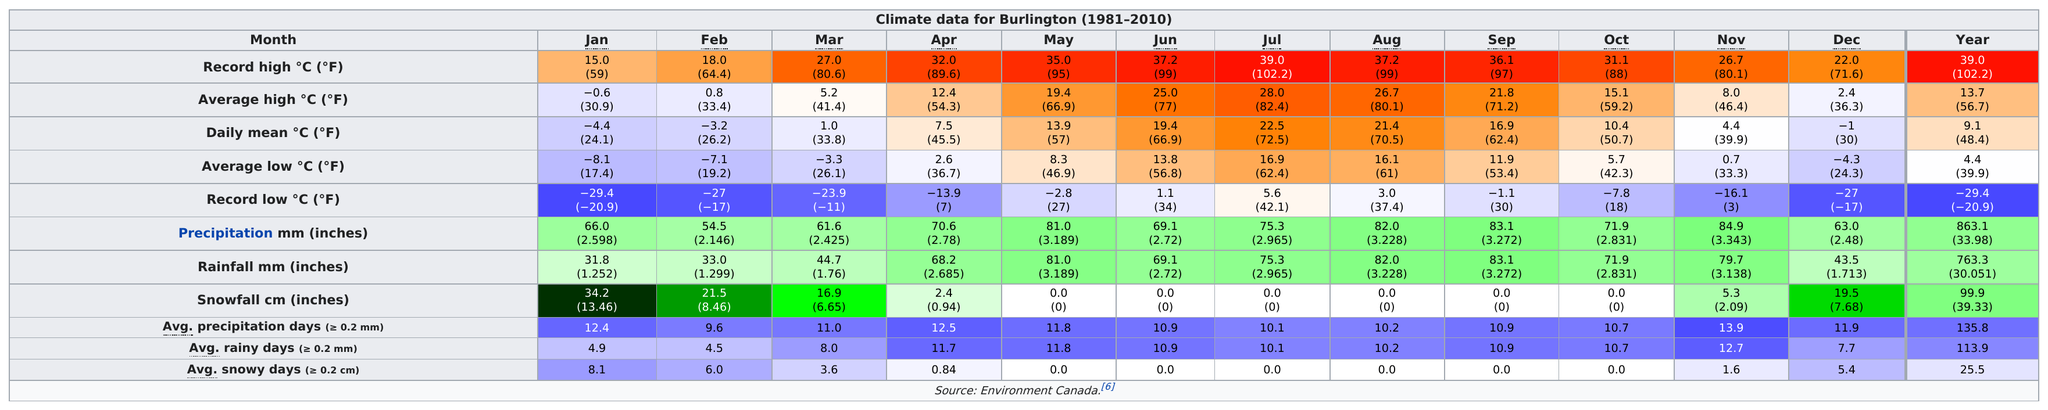Identify some key points in this picture. Eleven months set a record high of over 15.0 degrees. Between January, October, and December, October was the month that received the greatest amount of rainfall. In the month of September, the average high temperature was 21.8 degrees and the record low temperature was -1.1 degrees. 